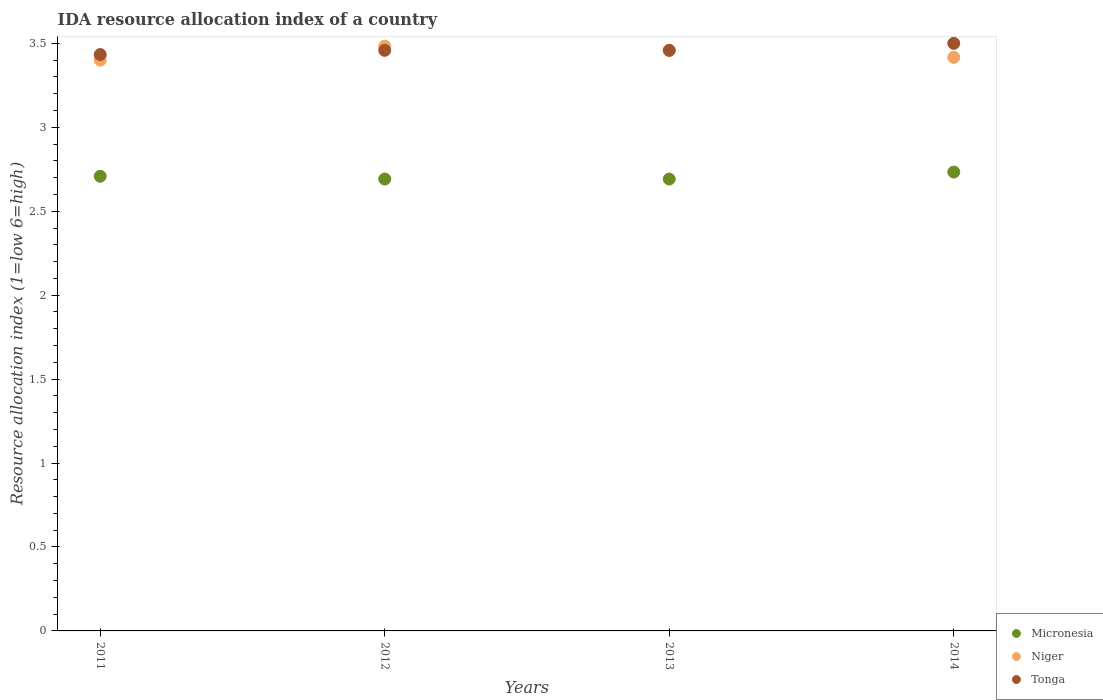How many different coloured dotlines are there?
Offer a very short reply. 3. Is the number of dotlines equal to the number of legend labels?
Offer a terse response. Yes. What is the IDA resource allocation index in Niger in 2014?
Your answer should be compact. 3.42. Across all years, what is the maximum IDA resource allocation index in Micronesia?
Offer a very short reply. 2.73. In which year was the IDA resource allocation index in Niger maximum?
Keep it short and to the point. 2012. What is the total IDA resource allocation index in Micronesia in the graph?
Offer a terse response. 10.82. What is the difference between the IDA resource allocation index in Niger in 2011 and that in 2014?
Your response must be concise. -0.02. What is the difference between the IDA resource allocation index in Tonga in 2011 and the IDA resource allocation index in Micronesia in 2014?
Provide a succinct answer. 0.7. What is the average IDA resource allocation index in Micronesia per year?
Offer a very short reply. 2.71. In the year 2013, what is the difference between the IDA resource allocation index in Niger and IDA resource allocation index in Micronesia?
Keep it short and to the point. 0.77. What is the ratio of the IDA resource allocation index in Niger in 2012 to that in 2013?
Keep it short and to the point. 1.01. Is the IDA resource allocation index in Micronesia in 2011 less than that in 2012?
Give a very brief answer. No. Is the difference between the IDA resource allocation index in Niger in 2011 and 2013 greater than the difference between the IDA resource allocation index in Micronesia in 2011 and 2013?
Provide a succinct answer. No. What is the difference between the highest and the second highest IDA resource allocation index in Tonga?
Your answer should be very brief. 0.04. What is the difference between the highest and the lowest IDA resource allocation index in Micronesia?
Make the answer very short. 0.04. Is the sum of the IDA resource allocation index in Niger in 2012 and 2013 greater than the maximum IDA resource allocation index in Tonga across all years?
Provide a succinct answer. Yes. Is it the case that in every year, the sum of the IDA resource allocation index in Tonga and IDA resource allocation index in Niger  is greater than the IDA resource allocation index in Micronesia?
Your response must be concise. Yes. Does the IDA resource allocation index in Micronesia monotonically increase over the years?
Your answer should be very brief. No. Is the IDA resource allocation index in Niger strictly greater than the IDA resource allocation index in Tonga over the years?
Provide a succinct answer. No. How many dotlines are there?
Give a very brief answer. 3. Are the values on the major ticks of Y-axis written in scientific E-notation?
Provide a succinct answer. No. Does the graph contain any zero values?
Provide a succinct answer. No. Does the graph contain grids?
Keep it short and to the point. No. How are the legend labels stacked?
Keep it short and to the point. Vertical. What is the title of the graph?
Make the answer very short. IDA resource allocation index of a country. Does "Caribbean small states" appear as one of the legend labels in the graph?
Keep it short and to the point. No. What is the label or title of the X-axis?
Offer a very short reply. Years. What is the label or title of the Y-axis?
Make the answer very short. Resource allocation index (1=low 6=high). What is the Resource allocation index (1=low 6=high) in Micronesia in 2011?
Keep it short and to the point. 2.71. What is the Resource allocation index (1=low 6=high) in Niger in 2011?
Your response must be concise. 3.4. What is the Resource allocation index (1=low 6=high) in Tonga in 2011?
Your answer should be very brief. 3.43. What is the Resource allocation index (1=low 6=high) of Micronesia in 2012?
Keep it short and to the point. 2.69. What is the Resource allocation index (1=low 6=high) in Niger in 2012?
Keep it short and to the point. 3.48. What is the Resource allocation index (1=low 6=high) of Tonga in 2012?
Your response must be concise. 3.46. What is the Resource allocation index (1=low 6=high) of Micronesia in 2013?
Offer a terse response. 2.69. What is the Resource allocation index (1=low 6=high) of Niger in 2013?
Keep it short and to the point. 3.46. What is the Resource allocation index (1=low 6=high) in Tonga in 2013?
Keep it short and to the point. 3.46. What is the Resource allocation index (1=low 6=high) in Micronesia in 2014?
Give a very brief answer. 2.73. What is the Resource allocation index (1=low 6=high) of Niger in 2014?
Ensure brevity in your answer.  3.42. What is the Resource allocation index (1=low 6=high) of Tonga in 2014?
Your answer should be compact. 3.5. Across all years, what is the maximum Resource allocation index (1=low 6=high) of Micronesia?
Your answer should be compact. 2.73. Across all years, what is the maximum Resource allocation index (1=low 6=high) of Niger?
Offer a very short reply. 3.48. Across all years, what is the minimum Resource allocation index (1=low 6=high) of Micronesia?
Offer a terse response. 2.69. Across all years, what is the minimum Resource allocation index (1=low 6=high) in Niger?
Keep it short and to the point. 3.4. Across all years, what is the minimum Resource allocation index (1=low 6=high) of Tonga?
Make the answer very short. 3.43. What is the total Resource allocation index (1=low 6=high) in Micronesia in the graph?
Provide a succinct answer. 10.82. What is the total Resource allocation index (1=low 6=high) in Niger in the graph?
Your answer should be compact. 13.76. What is the total Resource allocation index (1=low 6=high) in Tonga in the graph?
Make the answer very short. 13.85. What is the difference between the Resource allocation index (1=low 6=high) in Micronesia in 2011 and that in 2012?
Ensure brevity in your answer.  0.02. What is the difference between the Resource allocation index (1=low 6=high) of Niger in 2011 and that in 2012?
Offer a terse response. -0.08. What is the difference between the Resource allocation index (1=low 6=high) of Tonga in 2011 and that in 2012?
Keep it short and to the point. -0.03. What is the difference between the Resource allocation index (1=low 6=high) of Micronesia in 2011 and that in 2013?
Your answer should be compact. 0.02. What is the difference between the Resource allocation index (1=low 6=high) in Niger in 2011 and that in 2013?
Provide a short and direct response. -0.06. What is the difference between the Resource allocation index (1=low 6=high) in Tonga in 2011 and that in 2013?
Provide a short and direct response. -0.03. What is the difference between the Resource allocation index (1=low 6=high) of Micronesia in 2011 and that in 2014?
Keep it short and to the point. -0.03. What is the difference between the Resource allocation index (1=low 6=high) of Niger in 2011 and that in 2014?
Your response must be concise. -0.02. What is the difference between the Resource allocation index (1=low 6=high) of Tonga in 2011 and that in 2014?
Your answer should be compact. -0.07. What is the difference between the Resource allocation index (1=low 6=high) in Niger in 2012 and that in 2013?
Your answer should be compact. 0.03. What is the difference between the Resource allocation index (1=low 6=high) of Micronesia in 2012 and that in 2014?
Your response must be concise. -0.04. What is the difference between the Resource allocation index (1=low 6=high) of Niger in 2012 and that in 2014?
Provide a succinct answer. 0.07. What is the difference between the Resource allocation index (1=low 6=high) in Tonga in 2012 and that in 2014?
Offer a very short reply. -0.04. What is the difference between the Resource allocation index (1=low 6=high) of Micronesia in 2013 and that in 2014?
Provide a succinct answer. -0.04. What is the difference between the Resource allocation index (1=low 6=high) of Niger in 2013 and that in 2014?
Make the answer very short. 0.04. What is the difference between the Resource allocation index (1=low 6=high) in Tonga in 2013 and that in 2014?
Your response must be concise. -0.04. What is the difference between the Resource allocation index (1=low 6=high) in Micronesia in 2011 and the Resource allocation index (1=low 6=high) in Niger in 2012?
Provide a succinct answer. -0.78. What is the difference between the Resource allocation index (1=low 6=high) of Micronesia in 2011 and the Resource allocation index (1=low 6=high) of Tonga in 2012?
Your answer should be very brief. -0.75. What is the difference between the Resource allocation index (1=low 6=high) in Niger in 2011 and the Resource allocation index (1=low 6=high) in Tonga in 2012?
Your response must be concise. -0.06. What is the difference between the Resource allocation index (1=low 6=high) in Micronesia in 2011 and the Resource allocation index (1=low 6=high) in Niger in 2013?
Offer a terse response. -0.75. What is the difference between the Resource allocation index (1=low 6=high) in Micronesia in 2011 and the Resource allocation index (1=low 6=high) in Tonga in 2013?
Provide a succinct answer. -0.75. What is the difference between the Resource allocation index (1=low 6=high) in Niger in 2011 and the Resource allocation index (1=low 6=high) in Tonga in 2013?
Keep it short and to the point. -0.06. What is the difference between the Resource allocation index (1=low 6=high) in Micronesia in 2011 and the Resource allocation index (1=low 6=high) in Niger in 2014?
Make the answer very short. -0.71. What is the difference between the Resource allocation index (1=low 6=high) of Micronesia in 2011 and the Resource allocation index (1=low 6=high) of Tonga in 2014?
Make the answer very short. -0.79. What is the difference between the Resource allocation index (1=low 6=high) of Micronesia in 2012 and the Resource allocation index (1=low 6=high) of Niger in 2013?
Provide a short and direct response. -0.77. What is the difference between the Resource allocation index (1=low 6=high) of Micronesia in 2012 and the Resource allocation index (1=low 6=high) of Tonga in 2013?
Provide a short and direct response. -0.77. What is the difference between the Resource allocation index (1=low 6=high) of Niger in 2012 and the Resource allocation index (1=low 6=high) of Tonga in 2013?
Keep it short and to the point. 0.03. What is the difference between the Resource allocation index (1=low 6=high) in Micronesia in 2012 and the Resource allocation index (1=low 6=high) in Niger in 2014?
Offer a terse response. -0.72. What is the difference between the Resource allocation index (1=low 6=high) of Micronesia in 2012 and the Resource allocation index (1=low 6=high) of Tonga in 2014?
Provide a short and direct response. -0.81. What is the difference between the Resource allocation index (1=low 6=high) of Niger in 2012 and the Resource allocation index (1=low 6=high) of Tonga in 2014?
Give a very brief answer. -0.02. What is the difference between the Resource allocation index (1=low 6=high) of Micronesia in 2013 and the Resource allocation index (1=low 6=high) of Niger in 2014?
Your answer should be very brief. -0.72. What is the difference between the Resource allocation index (1=low 6=high) of Micronesia in 2013 and the Resource allocation index (1=low 6=high) of Tonga in 2014?
Offer a terse response. -0.81. What is the difference between the Resource allocation index (1=low 6=high) in Niger in 2013 and the Resource allocation index (1=low 6=high) in Tonga in 2014?
Make the answer very short. -0.04. What is the average Resource allocation index (1=low 6=high) in Micronesia per year?
Provide a short and direct response. 2.71. What is the average Resource allocation index (1=low 6=high) of Niger per year?
Provide a short and direct response. 3.44. What is the average Resource allocation index (1=low 6=high) of Tonga per year?
Provide a short and direct response. 3.46. In the year 2011, what is the difference between the Resource allocation index (1=low 6=high) of Micronesia and Resource allocation index (1=low 6=high) of Niger?
Keep it short and to the point. -0.69. In the year 2011, what is the difference between the Resource allocation index (1=low 6=high) in Micronesia and Resource allocation index (1=low 6=high) in Tonga?
Offer a terse response. -0.72. In the year 2011, what is the difference between the Resource allocation index (1=low 6=high) in Niger and Resource allocation index (1=low 6=high) in Tonga?
Provide a short and direct response. -0.03. In the year 2012, what is the difference between the Resource allocation index (1=low 6=high) in Micronesia and Resource allocation index (1=low 6=high) in Niger?
Offer a terse response. -0.79. In the year 2012, what is the difference between the Resource allocation index (1=low 6=high) of Micronesia and Resource allocation index (1=low 6=high) of Tonga?
Ensure brevity in your answer.  -0.77. In the year 2012, what is the difference between the Resource allocation index (1=low 6=high) of Niger and Resource allocation index (1=low 6=high) of Tonga?
Offer a terse response. 0.03. In the year 2013, what is the difference between the Resource allocation index (1=low 6=high) in Micronesia and Resource allocation index (1=low 6=high) in Niger?
Make the answer very short. -0.77. In the year 2013, what is the difference between the Resource allocation index (1=low 6=high) in Micronesia and Resource allocation index (1=low 6=high) in Tonga?
Provide a succinct answer. -0.77. In the year 2013, what is the difference between the Resource allocation index (1=low 6=high) in Niger and Resource allocation index (1=low 6=high) in Tonga?
Your answer should be very brief. 0. In the year 2014, what is the difference between the Resource allocation index (1=low 6=high) in Micronesia and Resource allocation index (1=low 6=high) in Niger?
Your answer should be very brief. -0.68. In the year 2014, what is the difference between the Resource allocation index (1=low 6=high) of Micronesia and Resource allocation index (1=low 6=high) of Tonga?
Give a very brief answer. -0.77. In the year 2014, what is the difference between the Resource allocation index (1=low 6=high) of Niger and Resource allocation index (1=low 6=high) of Tonga?
Offer a very short reply. -0.08. What is the ratio of the Resource allocation index (1=low 6=high) in Micronesia in 2011 to that in 2012?
Your answer should be very brief. 1.01. What is the ratio of the Resource allocation index (1=low 6=high) of Niger in 2011 to that in 2012?
Provide a short and direct response. 0.98. What is the ratio of the Resource allocation index (1=low 6=high) in Tonga in 2011 to that in 2012?
Your answer should be compact. 0.99. What is the ratio of the Resource allocation index (1=low 6=high) in Niger in 2011 to that in 2013?
Provide a short and direct response. 0.98. What is the ratio of the Resource allocation index (1=low 6=high) of Tonga in 2011 to that in 2013?
Offer a very short reply. 0.99. What is the ratio of the Resource allocation index (1=low 6=high) in Micronesia in 2011 to that in 2014?
Provide a succinct answer. 0.99. What is the ratio of the Resource allocation index (1=low 6=high) of Niger in 2011 to that in 2014?
Make the answer very short. 1. What is the ratio of the Resource allocation index (1=low 6=high) of Micronesia in 2012 to that in 2013?
Your answer should be compact. 1. What is the ratio of the Resource allocation index (1=low 6=high) in Niger in 2012 to that in 2013?
Provide a short and direct response. 1.01. What is the ratio of the Resource allocation index (1=low 6=high) in Tonga in 2012 to that in 2013?
Your answer should be compact. 1. What is the ratio of the Resource allocation index (1=low 6=high) in Micronesia in 2012 to that in 2014?
Your answer should be compact. 0.98. What is the ratio of the Resource allocation index (1=low 6=high) of Niger in 2012 to that in 2014?
Ensure brevity in your answer.  1.02. What is the ratio of the Resource allocation index (1=low 6=high) in Micronesia in 2013 to that in 2014?
Give a very brief answer. 0.98. What is the ratio of the Resource allocation index (1=low 6=high) of Niger in 2013 to that in 2014?
Your response must be concise. 1.01. What is the ratio of the Resource allocation index (1=low 6=high) of Tonga in 2013 to that in 2014?
Offer a terse response. 0.99. What is the difference between the highest and the second highest Resource allocation index (1=low 6=high) of Micronesia?
Your answer should be very brief. 0.03. What is the difference between the highest and the second highest Resource allocation index (1=low 6=high) in Niger?
Provide a succinct answer. 0.03. What is the difference between the highest and the second highest Resource allocation index (1=low 6=high) in Tonga?
Give a very brief answer. 0.04. What is the difference between the highest and the lowest Resource allocation index (1=low 6=high) of Micronesia?
Give a very brief answer. 0.04. What is the difference between the highest and the lowest Resource allocation index (1=low 6=high) in Niger?
Offer a terse response. 0.08. What is the difference between the highest and the lowest Resource allocation index (1=low 6=high) of Tonga?
Ensure brevity in your answer.  0.07. 